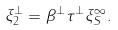<formula> <loc_0><loc_0><loc_500><loc_500>\xi ^ { \perp } _ { 2 } = \beta ^ { \perp } \tau ^ { \perp } \xi _ { S } ^ { \infty } .</formula> 